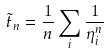<formula> <loc_0><loc_0><loc_500><loc_500>\tilde { t } _ { n } = \frac { 1 } { n } \sum _ { i } \frac { 1 } { \eta _ { i } ^ { n } }</formula> 